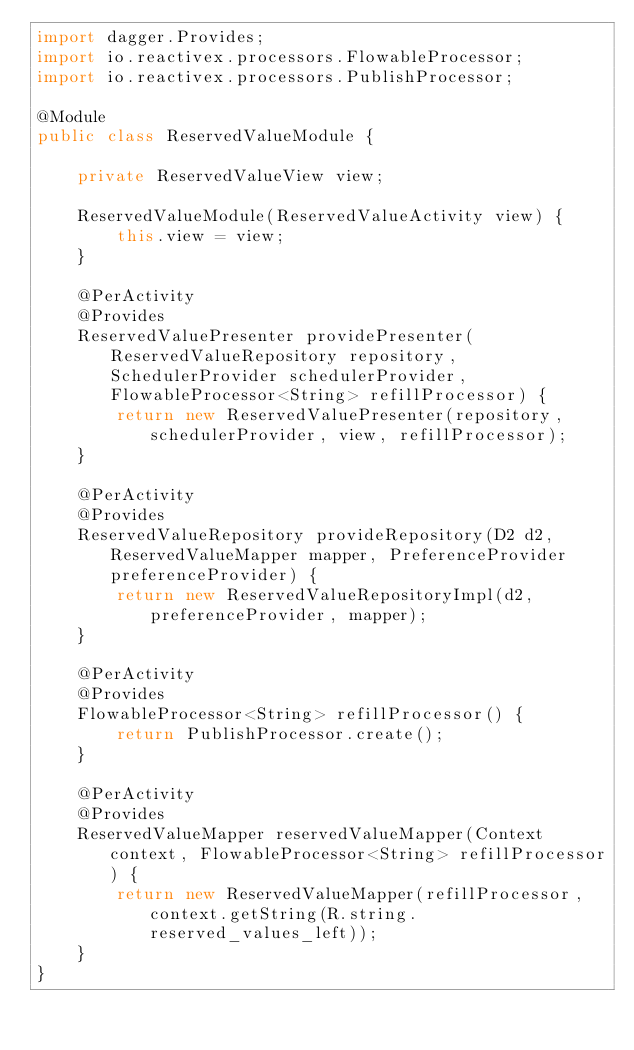Convert code to text. <code><loc_0><loc_0><loc_500><loc_500><_Java_>import dagger.Provides;
import io.reactivex.processors.FlowableProcessor;
import io.reactivex.processors.PublishProcessor;

@Module
public class ReservedValueModule {

    private ReservedValueView view;

    ReservedValueModule(ReservedValueActivity view) {
        this.view = view;
    }

    @PerActivity
    @Provides
    ReservedValuePresenter providePresenter(ReservedValueRepository repository, SchedulerProvider schedulerProvider, FlowableProcessor<String> refillProcessor) {
        return new ReservedValuePresenter(repository, schedulerProvider, view, refillProcessor);
    }

    @PerActivity
    @Provides
    ReservedValueRepository provideRepository(D2 d2, ReservedValueMapper mapper, PreferenceProvider preferenceProvider) {
        return new ReservedValueRepositoryImpl(d2, preferenceProvider, mapper);
    }

    @PerActivity
    @Provides
    FlowableProcessor<String> refillProcessor() {
        return PublishProcessor.create();
    }

    @PerActivity
    @Provides
    ReservedValueMapper reservedValueMapper(Context context, FlowableProcessor<String> refillProcessor) {
        return new ReservedValueMapper(refillProcessor, context.getString(R.string.reserved_values_left));
    }
}
</code> 